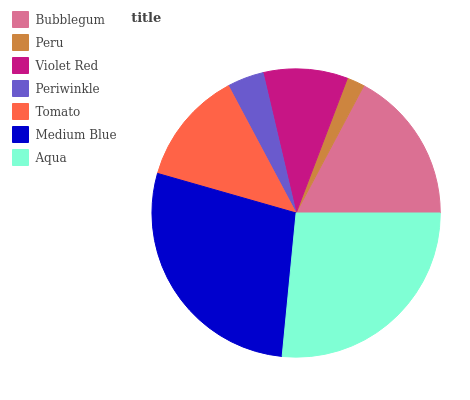Is Peru the minimum?
Answer yes or no. Yes. Is Medium Blue the maximum?
Answer yes or no. Yes. Is Violet Red the minimum?
Answer yes or no. No. Is Violet Red the maximum?
Answer yes or no. No. Is Violet Red greater than Peru?
Answer yes or no. Yes. Is Peru less than Violet Red?
Answer yes or no. Yes. Is Peru greater than Violet Red?
Answer yes or no. No. Is Violet Red less than Peru?
Answer yes or no. No. Is Tomato the high median?
Answer yes or no. Yes. Is Tomato the low median?
Answer yes or no. Yes. Is Aqua the high median?
Answer yes or no. No. Is Periwinkle the low median?
Answer yes or no. No. 